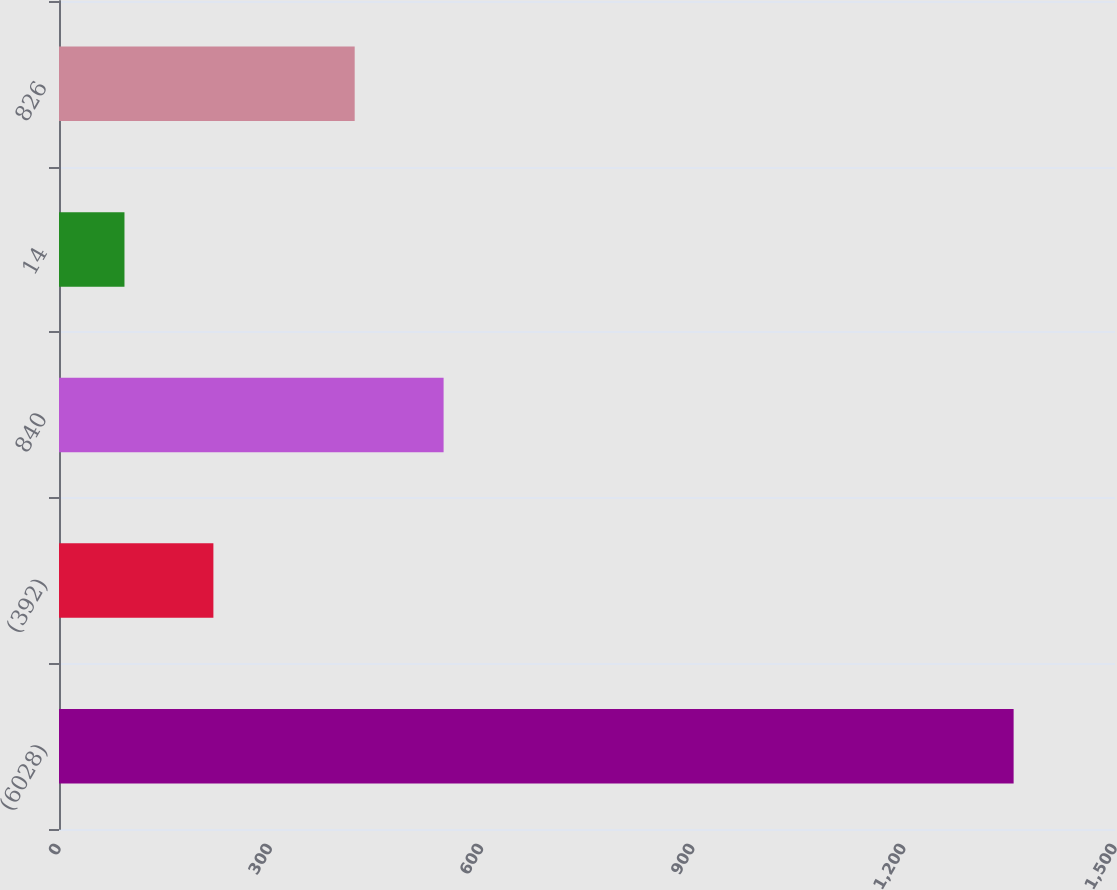Convert chart to OTSL. <chart><loc_0><loc_0><loc_500><loc_500><bar_chart><fcel>(6028)<fcel>(392)<fcel>840<fcel>14<fcel>826<nl><fcel>1356<fcel>219.3<fcel>546.3<fcel>93<fcel>420<nl></chart> 